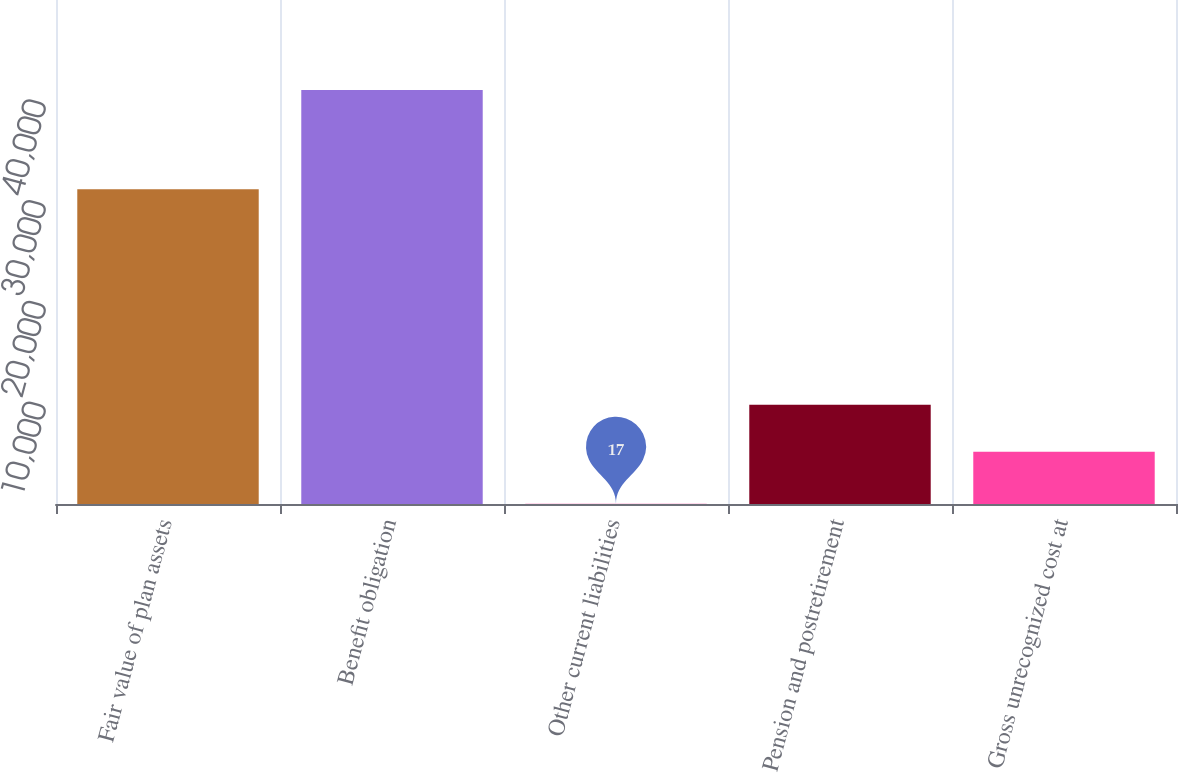Convert chart to OTSL. <chart><loc_0><loc_0><loc_500><loc_500><bar_chart><fcel>Fair value of plan assets<fcel>Benefit obligation<fcel>Other current liabilities<fcel>Pension and postretirement<fcel>Gross unrecognized cost at<nl><fcel>31215<fcel>41069<fcel>17<fcel>9837<fcel>5181<nl></chart> 